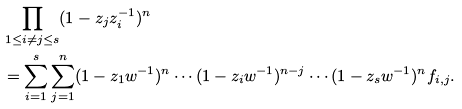Convert formula to latex. <formula><loc_0><loc_0><loc_500><loc_500>& \prod _ { 1 \leq i \neq j \leq s } ( 1 - z _ { j } z _ { i } ^ { - 1 } ) ^ { n } \\ & = \sum _ { i = 1 } ^ { s } \sum _ { j = 1 } ^ { n } ( 1 - z _ { 1 } w ^ { - 1 } ) ^ { n } \cdots ( 1 - z _ { i } w ^ { - 1 } ) ^ { n - j } \cdots ( 1 - z _ { s } w ^ { - 1 } ) ^ { n } f _ { i , j } .</formula> 